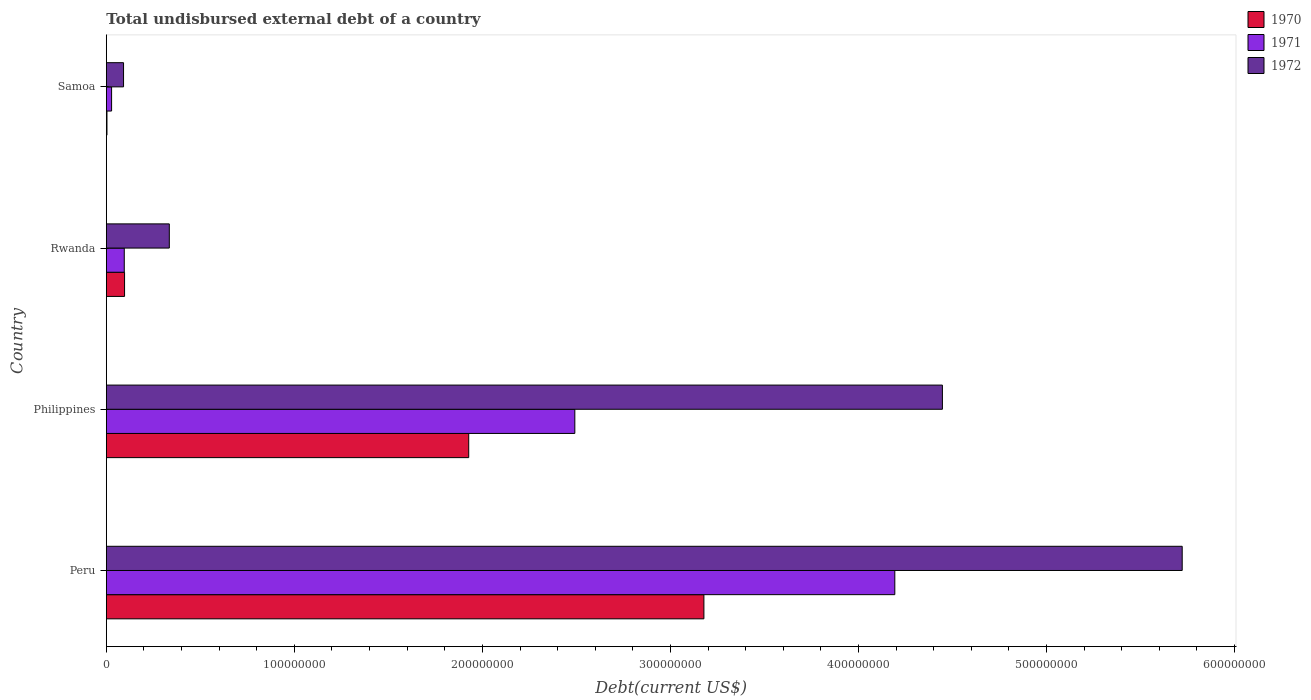How many different coloured bars are there?
Give a very brief answer. 3. How many groups of bars are there?
Ensure brevity in your answer.  4. Are the number of bars on each tick of the Y-axis equal?
Provide a short and direct response. Yes. How many bars are there on the 3rd tick from the top?
Provide a succinct answer. 3. How many bars are there on the 3rd tick from the bottom?
Provide a short and direct response. 3. In how many cases, is the number of bars for a given country not equal to the number of legend labels?
Your response must be concise. 0. What is the total undisbursed external debt in 1970 in Philippines?
Offer a terse response. 1.93e+08. Across all countries, what is the maximum total undisbursed external debt in 1972?
Offer a very short reply. 5.72e+08. Across all countries, what is the minimum total undisbursed external debt in 1970?
Offer a terse response. 3.36e+05. In which country was the total undisbursed external debt in 1970 minimum?
Keep it short and to the point. Samoa. What is the total total undisbursed external debt in 1972 in the graph?
Your answer should be very brief. 1.06e+09. What is the difference between the total undisbursed external debt in 1970 in Philippines and that in Rwanda?
Ensure brevity in your answer.  1.83e+08. What is the difference between the total undisbursed external debt in 1970 in Peru and the total undisbursed external debt in 1972 in Rwanda?
Your answer should be very brief. 2.84e+08. What is the average total undisbursed external debt in 1972 per country?
Give a very brief answer. 2.65e+08. What is the difference between the total undisbursed external debt in 1970 and total undisbursed external debt in 1971 in Samoa?
Your answer should be very brief. -2.46e+06. In how many countries, is the total undisbursed external debt in 1970 greater than 200000000 US$?
Your answer should be very brief. 1. What is the ratio of the total undisbursed external debt in 1970 in Rwanda to that in Samoa?
Offer a very short reply. 28.86. What is the difference between the highest and the second highest total undisbursed external debt in 1972?
Your answer should be compact. 1.28e+08. What is the difference between the highest and the lowest total undisbursed external debt in 1972?
Provide a succinct answer. 5.63e+08. What does the 1st bar from the top in Philippines represents?
Provide a succinct answer. 1972. How many countries are there in the graph?
Give a very brief answer. 4. What is the difference between two consecutive major ticks on the X-axis?
Ensure brevity in your answer.  1.00e+08. Does the graph contain any zero values?
Your answer should be very brief. No. Does the graph contain grids?
Give a very brief answer. No. How many legend labels are there?
Your answer should be compact. 3. How are the legend labels stacked?
Provide a succinct answer. Vertical. What is the title of the graph?
Keep it short and to the point. Total undisbursed external debt of a country. What is the label or title of the X-axis?
Provide a succinct answer. Debt(current US$). What is the Debt(current US$) of 1970 in Peru?
Give a very brief answer. 3.18e+08. What is the Debt(current US$) in 1971 in Peru?
Provide a short and direct response. 4.19e+08. What is the Debt(current US$) in 1972 in Peru?
Keep it short and to the point. 5.72e+08. What is the Debt(current US$) in 1970 in Philippines?
Ensure brevity in your answer.  1.93e+08. What is the Debt(current US$) of 1971 in Philippines?
Give a very brief answer. 2.49e+08. What is the Debt(current US$) in 1972 in Philippines?
Provide a succinct answer. 4.45e+08. What is the Debt(current US$) in 1970 in Rwanda?
Your response must be concise. 9.70e+06. What is the Debt(current US$) of 1971 in Rwanda?
Your answer should be compact. 9.53e+06. What is the Debt(current US$) in 1972 in Rwanda?
Your answer should be very brief. 3.35e+07. What is the Debt(current US$) in 1970 in Samoa?
Give a very brief answer. 3.36e+05. What is the Debt(current US$) of 1971 in Samoa?
Your answer should be compact. 2.80e+06. What is the Debt(current US$) in 1972 in Samoa?
Your answer should be very brief. 9.15e+06. Across all countries, what is the maximum Debt(current US$) of 1970?
Offer a terse response. 3.18e+08. Across all countries, what is the maximum Debt(current US$) of 1971?
Make the answer very short. 4.19e+08. Across all countries, what is the maximum Debt(current US$) of 1972?
Provide a short and direct response. 5.72e+08. Across all countries, what is the minimum Debt(current US$) in 1970?
Offer a terse response. 3.36e+05. Across all countries, what is the minimum Debt(current US$) of 1971?
Give a very brief answer. 2.80e+06. Across all countries, what is the minimum Debt(current US$) in 1972?
Your response must be concise. 9.15e+06. What is the total Debt(current US$) in 1970 in the graph?
Provide a succinct answer. 5.21e+08. What is the total Debt(current US$) in 1971 in the graph?
Keep it short and to the point. 6.81e+08. What is the total Debt(current US$) in 1972 in the graph?
Make the answer very short. 1.06e+09. What is the difference between the Debt(current US$) of 1970 in Peru and that in Philippines?
Your answer should be compact. 1.25e+08. What is the difference between the Debt(current US$) of 1971 in Peru and that in Philippines?
Provide a succinct answer. 1.70e+08. What is the difference between the Debt(current US$) of 1972 in Peru and that in Philippines?
Offer a very short reply. 1.28e+08. What is the difference between the Debt(current US$) in 1970 in Peru and that in Rwanda?
Make the answer very short. 3.08e+08. What is the difference between the Debt(current US$) in 1971 in Peru and that in Rwanda?
Your response must be concise. 4.10e+08. What is the difference between the Debt(current US$) of 1972 in Peru and that in Rwanda?
Make the answer very short. 5.39e+08. What is the difference between the Debt(current US$) in 1970 in Peru and that in Samoa?
Keep it short and to the point. 3.17e+08. What is the difference between the Debt(current US$) of 1971 in Peru and that in Samoa?
Offer a terse response. 4.17e+08. What is the difference between the Debt(current US$) in 1972 in Peru and that in Samoa?
Your answer should be compact. 5.63e+08. What is the difference between the Debt(current US$) of 1970 in Philippines and that in Rwanda?
Ensure brevity in your answer.  1.83e+08. What is the difference between the Debt(current US$) in 1971 in Philippines and that in Rwanda?
Your answer should be very brief. 2.40e+08. What is the difference between the Debt(current US$) in 1972 in Philippines and that in Rwanda?
Ensure brevity in your answer.  4.11e+08. What is the difference between the Debt(current US$) of 1970 in Philippines and that in Samoa?
Your answer should be compact. 1.92e+08. What is the difference between the Debt(current US$) of 1971 in Philippines and that in Samoa?
Ensure brevity in your answer.  2.46e+08. What is the difference between the Debt(current US$) in 1972 in Philippines and that in Samoa?
Your response must be concise. 4.35e+08. What is the difference between the Debt(current US$) in 1970 in Rwanda and that in Samoa?
Provide a succinct answer. 9.36e+06. What is the difference between the Debt(current US$) in 1971 in Rwanda and that in Samoa?
Your answer should be compact. 6.73e+06. What is the difference between the Debt(current US$) of 1972 in Rwanda and that in Samoa?
Your answer should be compact. 2.43e+07. What is the difference between the Debt(current US$) in 1970 in Peru and the Debt(current US$) in 1971 in Philippines?
Provide a short and direct response. 6.86e+07. What is the difference between the Debt(current US$) in 1970 in Peru and the Debt(current US$) in 1972 in Philippines?
Your answer should be very brief. -1.27e+08. What is the difference between the Debt(current US$) in 1971 in Peru and the Debt(current US$) in 1972 in Philippines?
Make the answer very short. -2.53e+07. What is the difference between the Debt(current US$) in 1970 in Peru and the Debt(current US$) in 1971 in Rwanda?
Your response must be concise. 3.08e+08. What is the difference between the Debt(current US$) in 1970 in Peru and the Debt(current US$) in 1972 in Rwanda?
Give a very brief answer. 2.84e+08. What is the difference between the Debt(current US$) in 1971 in Peru and the Debt(current US$) in 1972 in Rwanda?
Your answer should be compact. 3.86e+08. What is the difference between the Debt(current US$) of 1970 in Peru and the Debt(current US$) of 1971 in Samoa?
Your answer should be very brief. 3.15e+08. What is the difference between the Debt(current US$) in 1970 in Peru and the Debt(current US$) in 1972 in Samoa?
Keep it short and to the point. 3.09e+08. What is the difference between the Debt(current US$) in 1971 in Peru and the Debt(current US$) in 1972 in Samoa?
Provide a short and direct response. 4.10e+08. What is the difference between the Debt(current US$) of 1970 in Philippines and the Debt(current US$) of 1971 in Rwanda?
Provide a short and direct response. 1.83e+08. What is the difference between the Debt(current US$) in 1970 in Philippines and the Debt(current US$) in 1972 in Rwanda?
Offer a terse response. 1.59e+08. What is the difference between the Debt(current US$) of 1971 in Philippines and the Debt(current US$) of 1972 in Rwanda?
Ensure brevity in your answer.  2.16e+08. What is the difference between the Debt(current US$) of 1970 in Philippines and the Debt(current US$) of 1971 in Samoa?
Your answer should be compact. 1.90e+08. What is the difference between the Debt(current US$) in 1970 in Philippines and the Debt(current US$) in 1972 in Samoa?
Make the answer very short. 1.84e+08. What is the difference between the Debt(current US$) of 1971 in Philippines and the Debt(current US$) of 1972 in Samoa?
Give a very brief answer. 2.40e+08. What is the difference between the Debt(current US$) in 1970 in Rwanda and the Debt(current US$) in 1971 in Samoa?
Provide a succinct answer. 6.90e+06. What is the difference between the Debt(current US$) of 1970 in Rwanda and the Debt(current US$) of 1972 in Samoa?
Ensure brevity in your answer.  5.45e+05. What is the difference between the Debt(current US$) in 1971 in Rwanda and the Debt(current US$) in 1972 in Samoa?
Your answer should be very brief. 3.82e+05. What is the average Debt(current US$) in 1970 per country?
Offer a very short reply. 1.30e+08. What is the average Debt(current US$) of 1971 per country?
Your response must be concise. 1.70e+08. What is the average Debt(current US$) in 1972 per country?
Provide a succinct answer. 2.65e+08. What is the difference between the Debt(current US$) in 1970 and Debt(current US$) in 1971 in Peru?
Give a very brief answer. -1.02e+08. What is the difference between the Debt(current US$) in 1970 and Debt(current US$) in 1972 in Peru?
Make the answer very short. -2.54e+08. What is the difference between the Debt(current US$) in 1971 and Debt(current US$) in 1972 in Peru?
Your answer should be very brief. -1.53e+08. What is the difference between the Debt(current US$) of 1970 and Debt(current US$) of 1971 in Philippines?
Offer a very short reply. -5.64e+07. What is the difference between the Debt(current US$) in 1970 and Debt(current US$) in 1972 in Philippines?
Keep it short and to the point. -2.52e+08. What is the difference between the Debt(current US$) of 1971 and Debt(current US$) of 1972 in Philippines?
Provide a short and direct response. -1.95e+08. What is the difference between the Debt(current US$) of 1970 and Debt(current US$) of 1971 in Rwanda?
Offer a terse response. 1.63e+05. What is the difference between the Debt(current US$) of 1970 and Debt(current US$) of 1972 in Rwanda?
Make the answer very short. -2.38e+07. What is the difference between the Debt(current US$) in 1971 and Debt(current US$) in 1972 in Rwanda?
Offer a terse response. -2.40e+07. What is the difference between the Debt(current US$) in 1970 and Debt(current US$) in 1971 in Samoa?
Ensure brevity in your answer.  -2.46e+06. What is the difference between the Debt(current US$) in 1970 and Debt(current US$) in 1972 in Samoa?
Keep it short and to the point. -8.82e+06. What is the difference between the Debt(current US$) in 1971 and Debt(current US$) in 1972 in Samoa?
Your response must be concise. -6.35e+06. What is the ratio of the Debt(current US$) of 1970 in Peru to that in Philippines?
Keep it short and to the point. 1.65. What is the ratio of the Debt(current US$) of 1971 in Peru to that in Philippines?
Give a very brief answer. 1.68. What is the ratio of the Debt(current US$) of 1972 in Peru to that in Philippines?
Keep it short and to the point. 1.29. What is the ratio of the Debt(current US$) in 1970 in Peru to that in Rwanda?
Offer a very short reply. 32.78. What is the ratio of the Debt(current US$) in 1971 in Peru to that in Rwanda?
Your answer should be very brief. 43.99. What is the ratio of the Debt(current US$) of 1972 in Peru to that in Rwanda?
Give a very brief answer. 17.08. What is the ratio of the Debt(current US$) in 1970 in Peru to that in Samoa?
Give a very brief answer. 945.85. What is the ratio of the Debt(current US$) in 1971 in Peru to that in Samoa?
Keep it short and to the point. 149.71. What is the ratio of the Debt(current US$) in 1972 in Peru to that in Samoa?
Your response must be concise. 62.53. What is the ratio of the Debt(current US$) of 1970 in Philippines to that in Rwanda?
Make the answer very short. 19.88. What is the ratio of the Debt(current US$) in 1971 in Philippines to that in Rwanda?
Your answer should be compact. 26.14. What is the ratio of the Debt(current US$) in 1972 in Philippines to that in Rwanda?
Your answer should be very brief. 13.28. What is the ratio of the Debt(current US$) in 1970 in Philippines to that in Samoa?
Offer a terse response. 573.59. What is the ratio of the Debt(current US$) of 1971 in Philippines to that in Samoa?
Your answer should be very brief. 88.95. What is the ratio of the Debt(current US$) in 1972 in Philippines to that in Samoa?
Offer a terse response. 48.59. What is the ratio of the Debt(current US$) of 1970 in Rwanda to that in Samoa?
Your response must be concise. 28.86. What is the ratio of the Debt(current US$) in 1971 in Rwanda to that in Samoa?
Offer a terse response. 3.4. What is the ratio of the Debt(current US$) in 1972 in Rwanda to that in Samoa?
Your response must be concise. 3.66. What is the difference between the highest and the second highest Debt(current US$) of 1970?
Ensure brevity in your answer.  1.25e+08. What is the difference between the highest and the second highest Debt(current US$) of 1971?
Your answer should be very brief. 1.70e+08. What is the difference between the highest and the second highest Debt(current US$) in 1972?
Keep it short and to the point. 1.28e+08. What is the difference between the highest and the lowest Debt(current US$) of 1970?
Provide a succinct answer. 3.17e+08. What is the difference between the highest and the lowest Debt(current US$) in 1971?
Provide a short and direct response. 4.17e+08. What is the difference between the highest and the lowest Debt(current US$) in 1972?
Make the answer very short. 5.63e+08. 